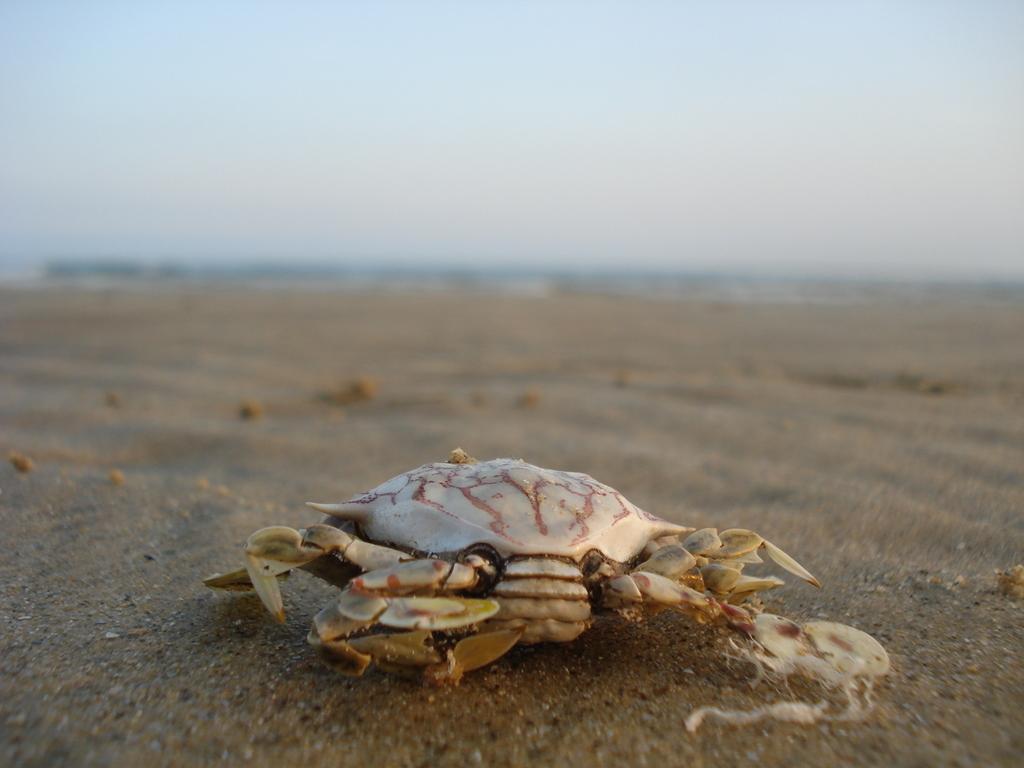Please provide a concise description of this image. In this picture I can see a crap on the sand. 